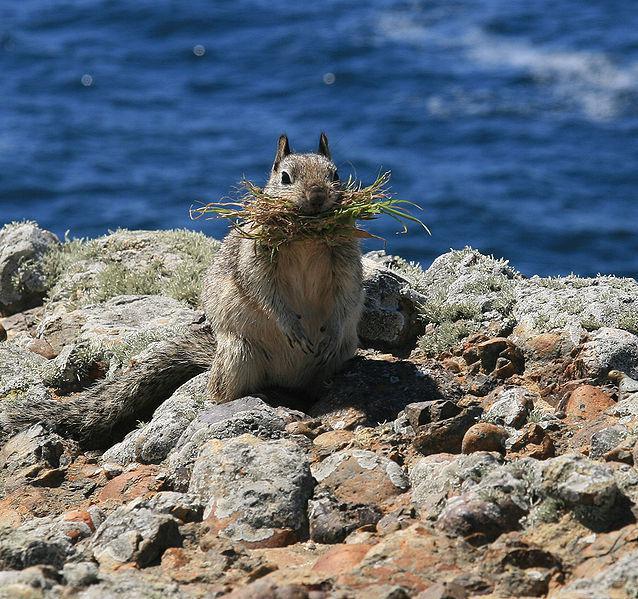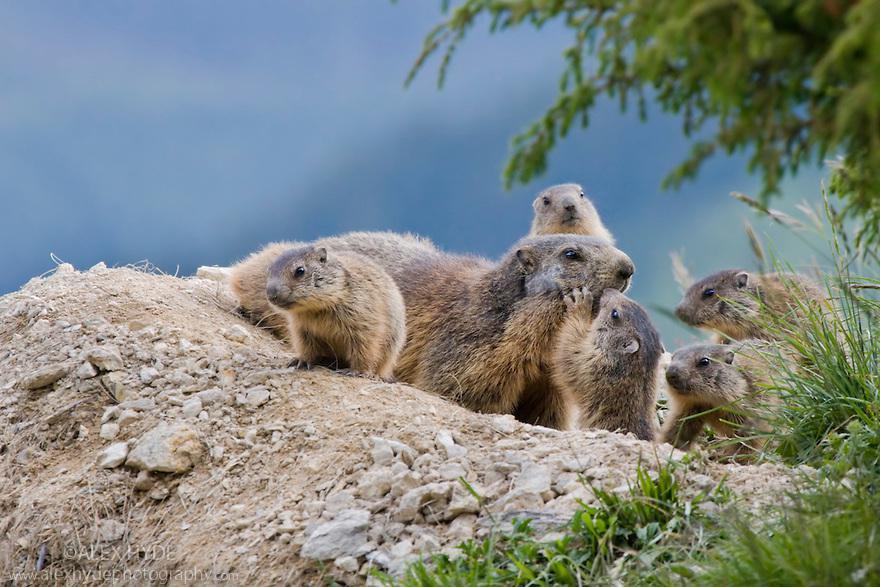The first image is the image on the left, the second image is the image on the right. Examine the images to the left and right. Is the description "The right image contains a rodent standing on grass." accurate? Answer yes or no. No. The first image is the image on the left, the second image is the image on the right. Evaluate the accuracy of this statement regarding the images: "A marmot is standing with its front paws raised towards its mouth in a clasping pose.". Is it true? Answer yes or no. No. 